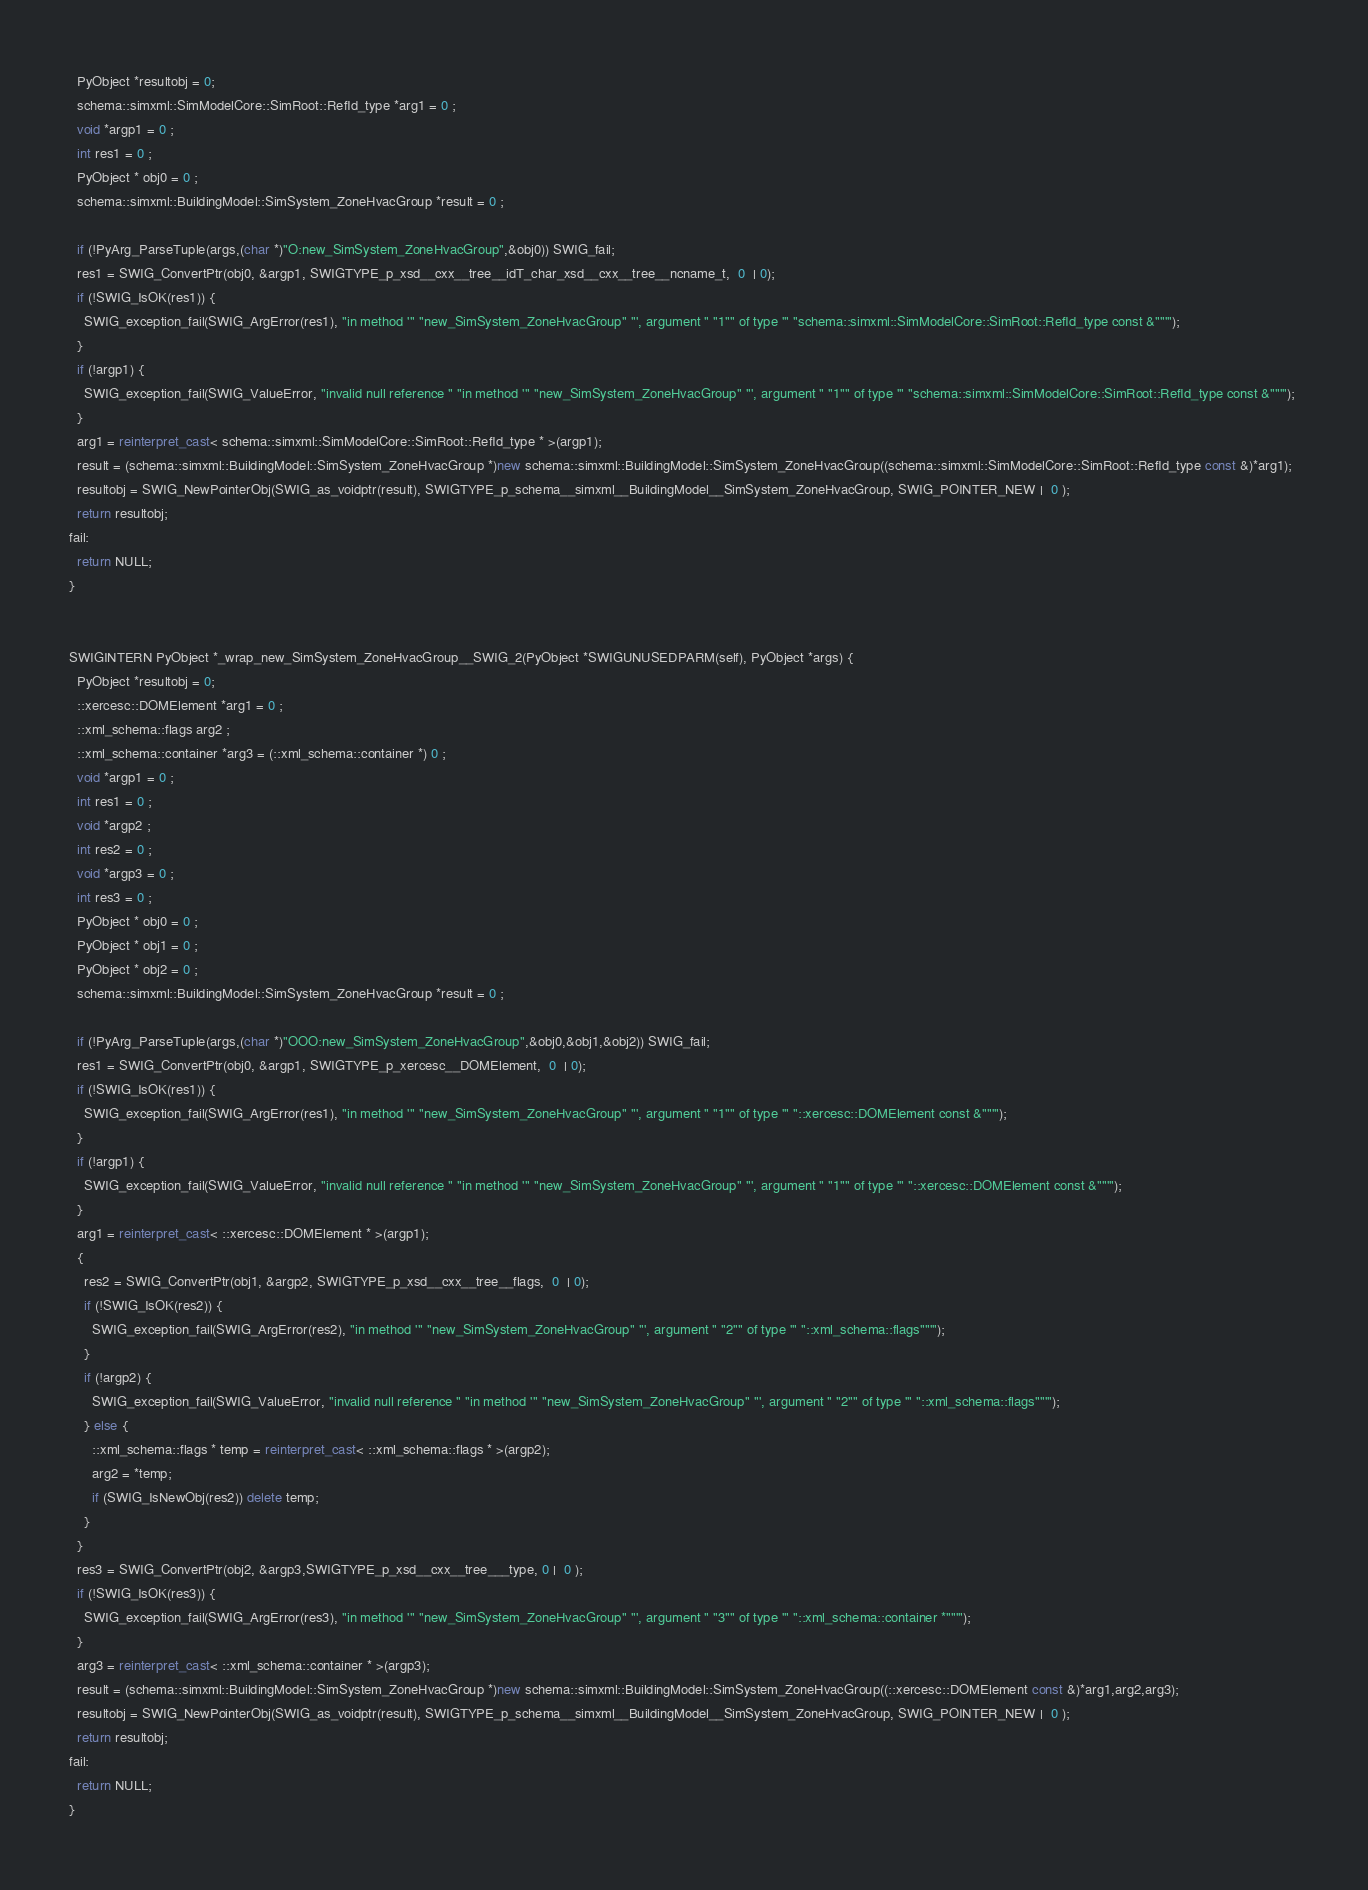Convert code to text. <code><loc_0><loc_0><loc_500><loc_500><_C++_>  PyObject *resultobj = 0;
  schema::simxml::SimModelCore::SimRoot::RefId_type *arg1 = 0 ;
  void *argp1 = 0 ;
  int res1 = 0 ;
  PyObject * obj0 = 0 ;
  schema::simxml::BuildingModel::SimSystem_ZoneHvacGroup *result = 0 ;
  
  if (!PyArg_ParseTuple(args,(char *)"O:new_SimSystem_ZoneHvacGroup",&obj0)) SWIG_fail;
  res1 = SWIG_ConvertPtr(obj0, &argp1, SWIGTYPE_p_xsd__cxx__tree__idT_char_xsd__cxx__tree__ncname_t,  0  | 0);
  if (!SWIG_IsOK(res1)) {
    SWIG_exception_fail(SWIG_ArgError(res1), "in method '" "new_SimSystem_ZoneHvacGroup" "', argument " "1"" of type '" "schema::simxml::SimModelCore::SimRoot::RefId_type const &""'"); 
  }
  if (!argp1) {
    SWIG_exception_fail(SWIG_ValueError, "invalid null reference " "in method '" "new_SimSystem_ZoneHvacGroup" "', argument " "1"" of type '" "schema::simxml::SimModelCore::SimRoot::RefId_type const &""'"); 
  }
  arg1 = reinterpret_cast< schema::simxml::SimModelCore::SimRoot::RefId_type * >(argp1);
  result = (schema::simxml::BuildingModel::SimSystem_ZoneHvacGroup *)new schema::simxml::BuildingModel::SimSystem_ZoneHvacGroup((schema::simxml::SimModelCore::SimRoot::RefId_type const &)*arg1);
  resultobj = SWIG_NewPointerObj(SWIG_as_voidptr(result), SWIGTYPE_p_schema__simxml__BuildingModel__SimSystem_ZoneHvacGroup, SWIG_POINTER_NEW |  0 );
  return resultobj;
fail:
  return NULL;
}


SWIGINTERN PyObject *_wrap_new_SimSystem_ZoneHvacGroup__SWIG_2(PyObject *SWIGUNUSEDPARM(self), PyObject *args) {
  PyObject *resultobj = 0;
  ::xercesc::DOMElement *arg1 = 0 ;
  ::xml_schema::flags arg2 ;
  ::xml_schema::container *arg3 = (::xml_schema::container *) 0 ;
  void *argp1 = 0 ;
  int res1 = 0 ;
  void *argp2 ;
  int res2 = 0 ;
  void *argp3 = 0 ;
  int res3 = 0 ;
  PyObject * obj0 = 0 ;
  PyObject * obj1 = 0 ;
  PyObject * obj2 = 0 ;
  schema::simxml::BuildingModel::SimSystem_ZoneHvacGroup *result = 0 ;
  
  if (!PyArg_ParseTuple(args,(char *)"OOO:new_SimSystem_ZoneHvacGroup",&obj0,&obj1,&obj2)) SWIG_fail;
  res1 = SWIG_ConvertPtr(obj0, &argp1, SWIGTYPE_p_xercesc__DOMElement,  0  | 0);
  if (!SWIG_IsOK(res1)) {
    SWIG_exception_fail(SWIG_ArgError(res1), "in method '" "new_SimSystem_ZoneHvacGroup" "', argument " "1"" of type '" "::xercesc::DOMElement const &""'"); 
  }
  if (!argp1) {
    SWIG_exception_fail(SWIG_ValueError, "invalid null reference " "in method '" "new_SimSystem_ZoneHvacGroup" "', argument " "1"" of type '" "::xercesc::DOMElement const &""'"); 
  }
  arg1 = reinterpret_cast< ::xercesc::DOMElement * >(argp1);
  {
    res2 = SWIG_ConvertPtr(obj1, &argp2, SWIGTYPE_p_xsd__cxx__tree__flags,  0  | 0);
    if (!SWIG_IsOK(res2)) {
      SWIG_exception_fail(SWIG_ArgError(res2), "in method '" "new_SimSystem_ZoneHvacGroup" "', argument " "2"" of type '" "::xml_schema::flags""'"); 
    }  
    if (!argp2) {
      SWIG_exception_fail(SWIG_ValueError, "invalid null reference " "in method '" "new_SimSystem_ZoneHvacGroup" "', argument " "2"" of type '" "::xml_schema::flags""'");
    } else {
      ::xml_schema::flags * temp = reinterpret_cast< ::xml_schema::flags * >(argp2);
      arg2 = *temp;
      if (SWIG_IsNewObj(res2)) delete temp;
    }
  }
  res3 = SWIG_ConvertPtr(obj2, &argp3,SWIGTYPE_p_xsd__cxx__tree___type, 0 |  0 );
  if (!SWIG_IsOK(res3)) {
    SWIG_exception_fail(SWIG_ArgError(res3), "in method '" "new_SimSystem_ZoneHvacGroup" "', argument " "3"" of type '" "::xml_schema::container *""'"); 
  }
  arg3 = reinterpret_cast< ::xml_schema::container * >(argp3);
  result = (schema::simxml::BuildingModel::SimSystem_ZoneHvacGroup *)new schema::simxml::BuildingModel::SimSystem_ZoneHvacGroup((::xercesc::DOMElement const &)*arg1,arg2,arg3);
  resultobj = SWIG_NewPointerObj(SWIG_as_voidptr(result), SWIGTYPE_p_schema__simxml__BuildingModel__SimSystem_ZoneHvacGroup, SWIG_POINTER_NEW |  0 );
  return resultobj;
fail:
  return NULL;
}

</code> 